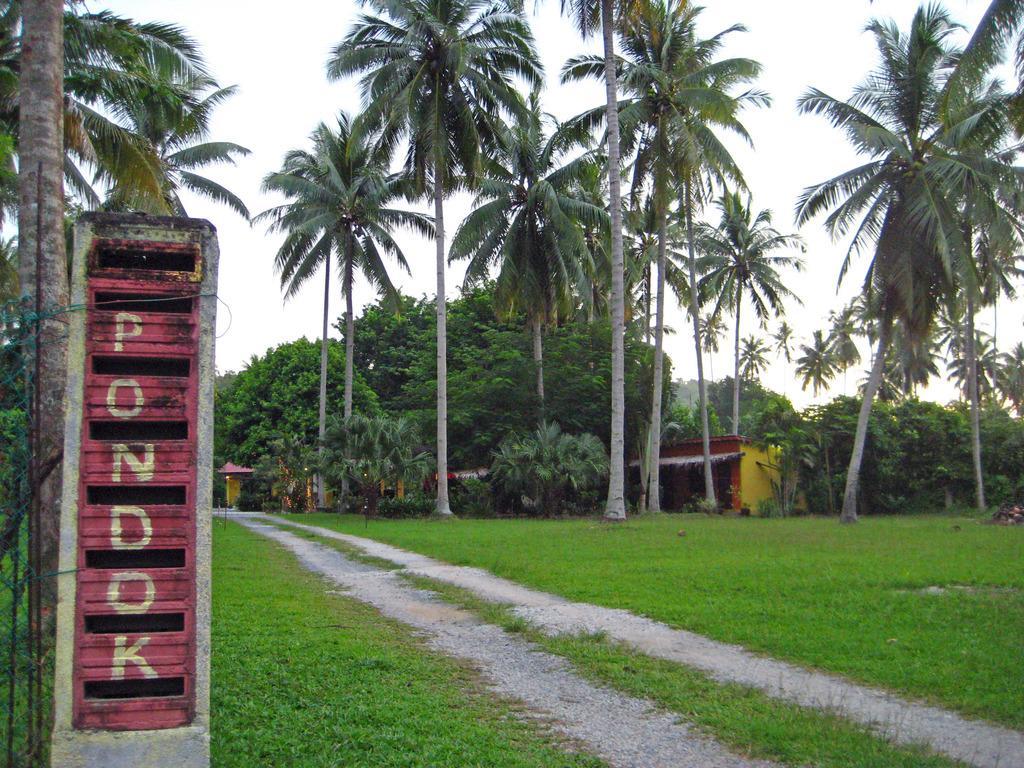In one or two sentences, can you explain what this image depicts? There is a grassy land at the bottom of this image. There is a house on the right side of this image. There are some trees in the background. There is a board with text on the left side of this image. There is a sky at the top of this image. 